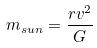Convert formula to latex. <formula><loc_0><loc_0><loc_500><loc_500>m _ { s u n } = \frac { r v ^ { 2 } } { G }</formula> 